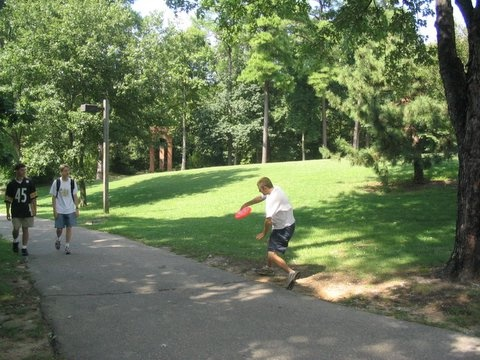Describe the objects in this image and their specific colors. I can see people in black, white, gray, and darkgray tones, people in black, gray, darkgray, and darkgreen tones, people in black, gray, and darkgreen tones, frisbee in black, salmon, and brown tones, and backpack in black and gray tones in this image. 